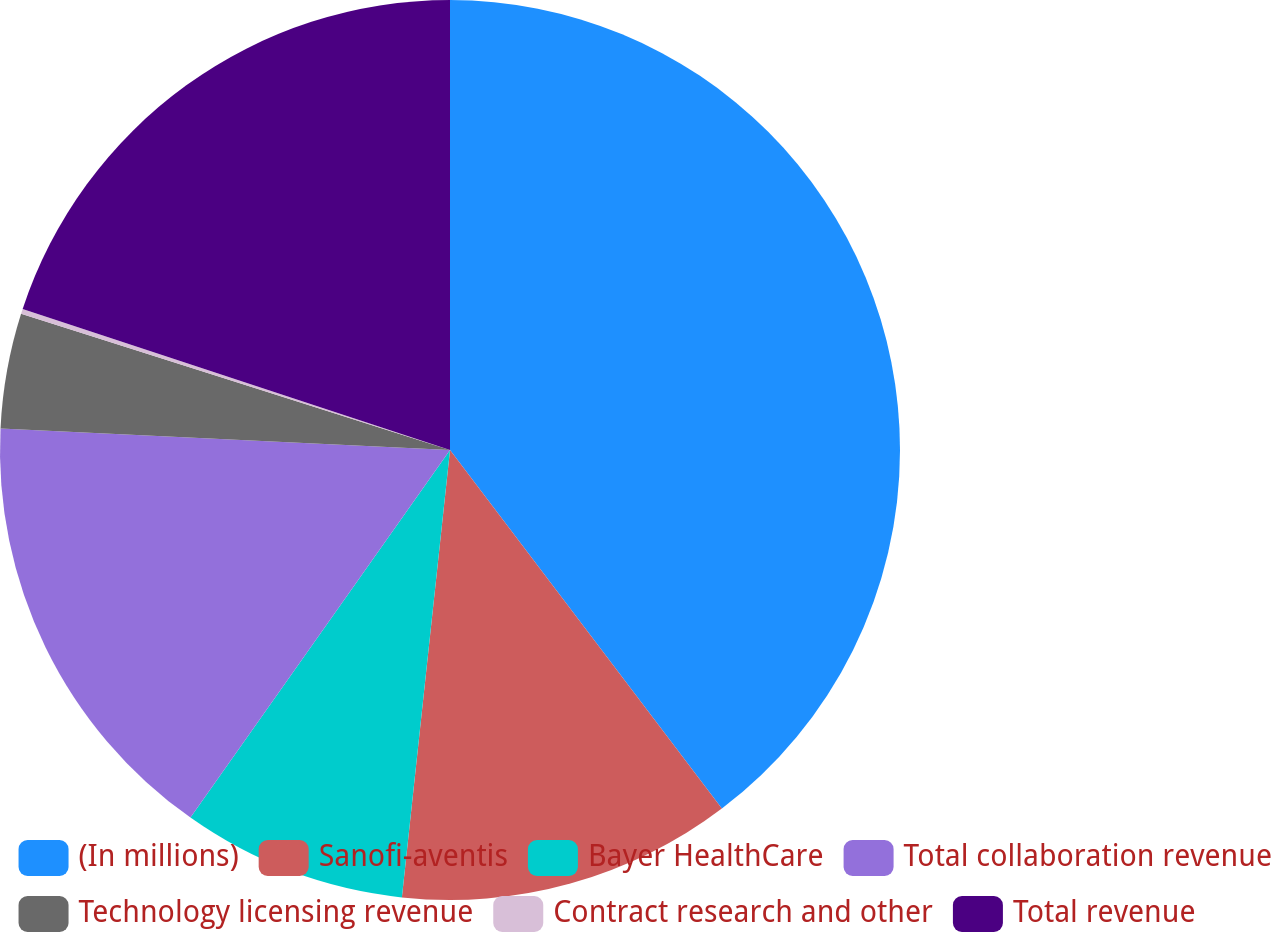<chart> <loc_0><loc_0><loc_500><loc_500><pie_chart><fcel>(In millions)<fcel>Sanofi-aventis<fcel>Bayer HealthCare<fcel>Total collaboration revenue<fcel>Technology licensing revenue<fcel>Contract research and other<fcel>Total revenue<nl><fcel>39.68%<fcel>12.03%<fcel>8.08%<fcel>15.98%<fcel>4.13%<fcel>0.18%<fcel>19.93%<nl></chart> 